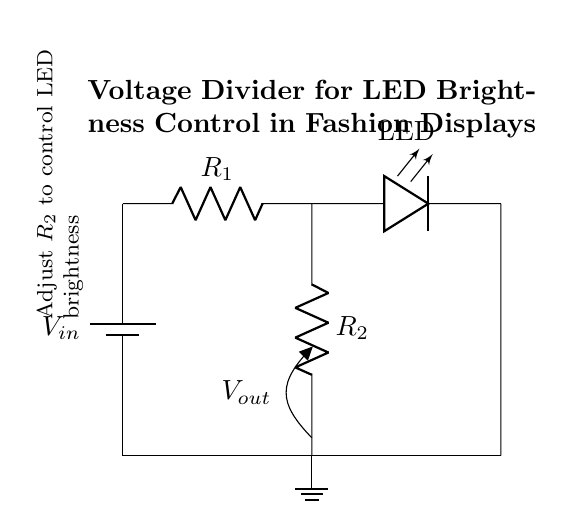What is the input voltage in this circuit? The input voltage is labeled as V_in at the top left of the circuit diagram, indicating the source voltage potentially powering the circuit.
Answer: V_in What are R_1 and R_2 in the circuit? R_1 and R_2 are the two resistors in the voltage divider configuration. They are connected in series, and their values determine the output voltage and LED brightness.
Answer: Resistors What is the function of the LED in this circuit? The LED is used for illumination in the fashion display, and its brightness is controlled by the output voltage from the voltage divider formed by R_1 and R_2.
Answer: Illumination How can you adjust the LED brightness? The brightness of the LED can be adjusted by changing the resistance of R_2; a higher resistance results in a lower output voltage, dimming the LED, while a lower resistance increases brightness.
Answer: Change R_2 Where is the output voltage measured in the circuit? The output voltage labeled as V_out is measured between the midpoint of the resistors R_1 and R_2, downward to the ground, indicating where the voltage for the LED is taken from.
Answer: Between R_1 and R_2 What is the role of the ground in this circuit? The ground serves as a reference point for the circuit, providing a return path for current and indicating zero voltage, allowing for proper function of the voltage divider.
Answer: Reference point 